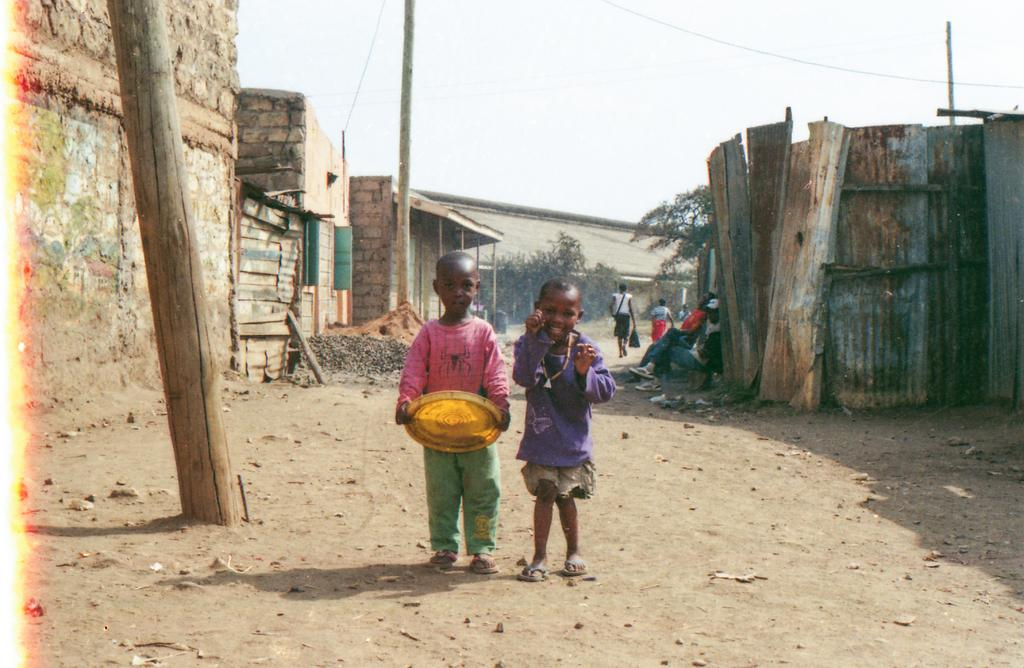How many kids are present in the image? There are two kids standing in the middle of the image. What can be seen behind the kids? There are trees at the back side of the image. What structures are visible on the sides of the image? There are houses on either side of the image. What is visible at the top of the image? The sky is visible at the top of the image. Where are the pigs located in the image? There are no pigs present in the image. What is the kids using to water the trees in the image? There is no hose or any watering tool visible in the image. 